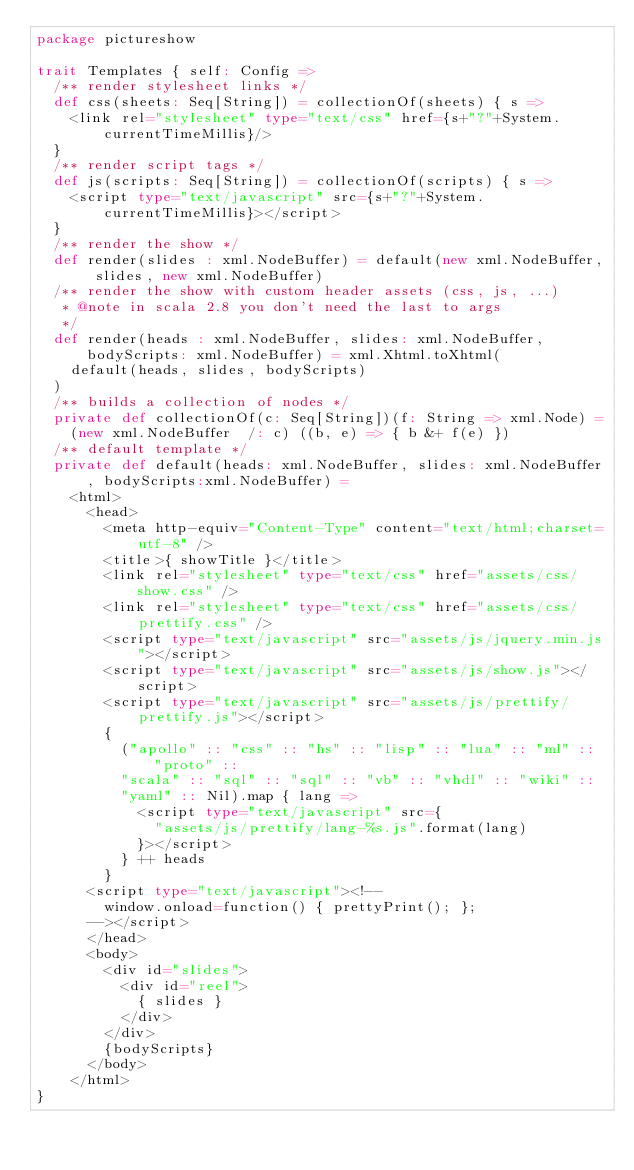Convert code to text. <code><loc_0><loc_0><loc_500><loc_500><_Scala_>package pictureshow

trait Templates { self: Config =>
  /** render stylesheet links */
  def css(sheets: Seq[String]) = collectionOf(sheets) { s =>
    <link rel="stylesheet" type="text/css" href={s+"?"+System.currentTimeMillis}/>
  }
  /** render script tags */
  def js(scripts: Seq[String]) = collectionOf(scripts) { s =>
    <script type="text/javascript" src={s+"?"+System.currentTimeMillis}></script>
  }
  /** render the show */
  def render(slides : xml.NodeBuffer) = default(new xml.NodeBuffer, slides, new xml.NodeBuffer)
  /** render the show with custom header assets (css, js, ...)
   * @note in scala 2.8 you don't need the last to args
   */
  def render(heads : xml.NodeBuffer, slides: xml.NodeBuffer, bodyScripts: xml.NodeBuffer) = xml.Xhtml.toXhtml(
    default(heads, slides, bodyScripts)
  )
  /** builds a collection of nodes */
  private def collectionOf(c: Seq[String])(f: String => xml.Node) =
    (new xml.NodeBuffer  /: c) ((b, e) => { b &+ f(e) })
  /** default template */
  private def default(heads: xml.NodeBuffer, slides: xml.NodeBuffer, bodyScripts:xml.NodeBuffer) =
    <html>
      <head>
        <meta http-equiv="Content-Type" content="text/html;charset=utf-8" />
        <title>{ showTitle }</title>
        <link rel="stylesheet" type="text/css" href="assets/css/show.css" />
        <link rel="stylesheet" type="text/css" href="assets/css/prettify.css" />
        <script type="text/javascript" src="assets/js/jquery.min.js"></script>
        <script type="text/javascript" src="assets/js/show.js"></script>
        <script type="text/javascript" src="assets/js/prettify/prettify.js"></script>
        {
          ("apollo" :: "css" :: "hs" :: "lisp" :: "lua" :: "ml" :: "proto" ::
          "scala" :: "sql" :: "sql" :: "vb" :: "vhdl" :: "wiki" :: 
          "yaml" :: Nil).map { lang =>
            <script type="text/javascript" src={
              "assets/js/prettify/lang-%s.js".format(lang)
            }></script>
          } ++ heads
        }
      <script type="text/javascript"><!--
        window.onload=function() { prettyPrint(); };
      --></script>
      </head>
      <body>
        <div id="slides">
          <div id="reel">
            { slides }
          </div>
        </div>
        {bodyScripts}
      </body>
    </html>
}
</code> 